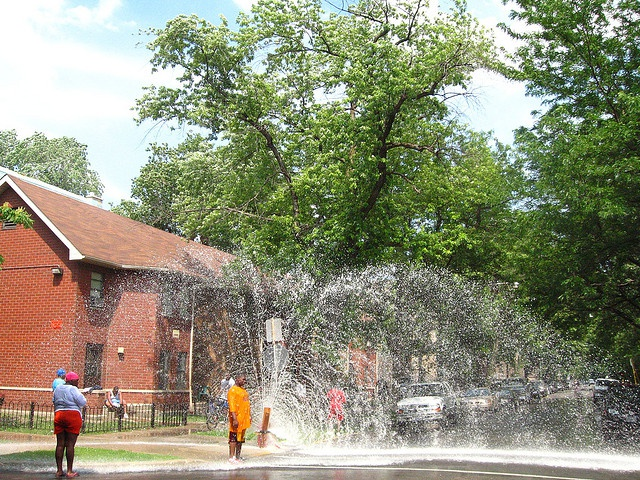Describe the objects in this image and their specific colors. I can see people in white, black, maroon, brown, and lavender tones, car in white, darkgray, lightgray, gray, and black tones, car in white, black, gray, and darkgray tones, people in white, orange, maroon, brown, and red tones, and people in white, lightgray, lightpink, and darkgray tones in this image. 